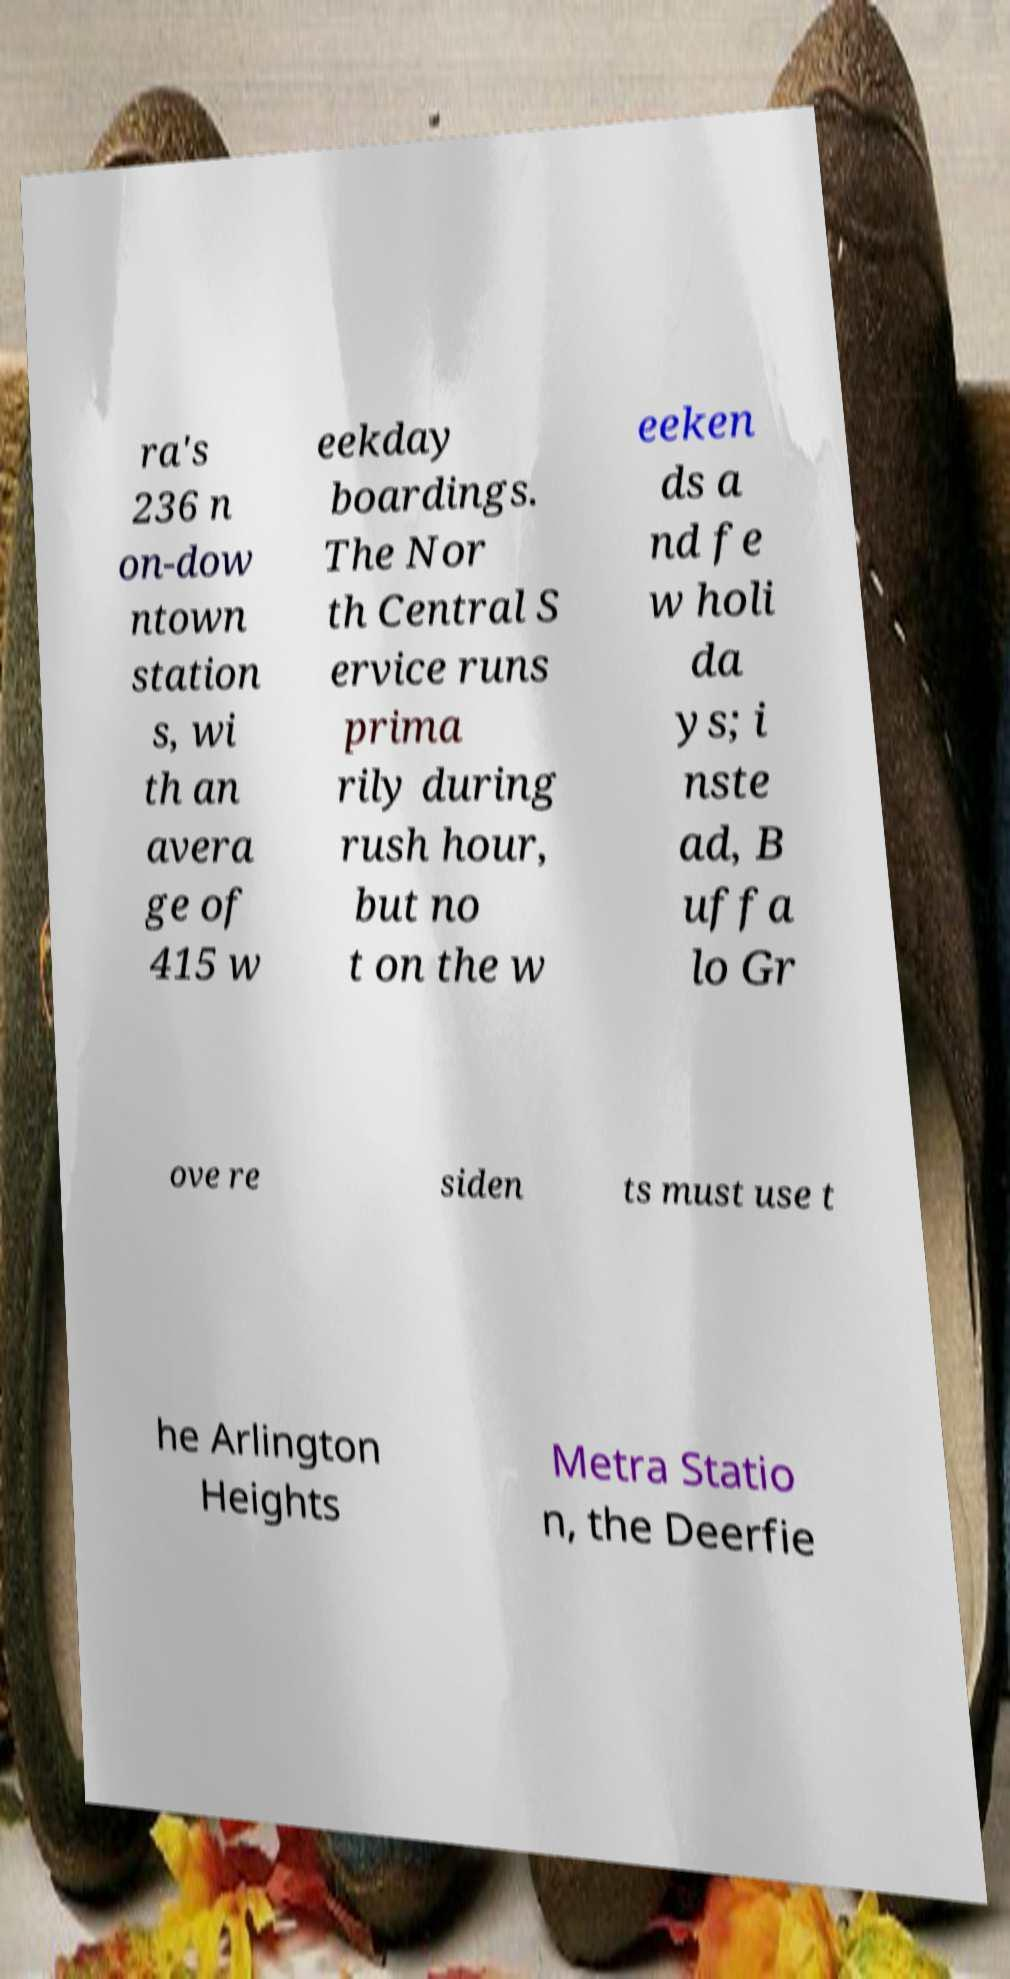Please read and relay the text visible in this image. What does it say? ra's 236 n on-dow ntown station s, wi th an avera ge of 415 w eekday boardings. The Nor th Central S ervice runs prima rily during rush hour, but no t on the w eeken ds a nd fe w holi da ys; i nste ad, B uffa lo Gr ove re siden ts must use t he Arlington Heights Metra Statio n, the Deerfie 